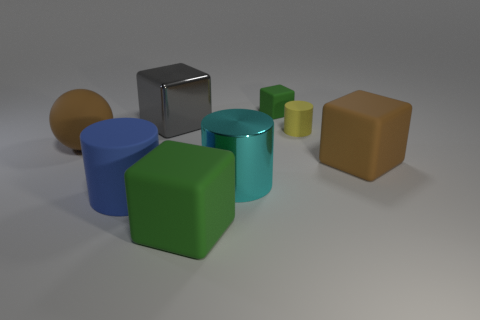There is a tiny object that is the same shape as the large cyan object; what color is it?
Keep it short and to the point. Yellow. There is a big matte ball that is to the left of the tiny yellow rubber thing; does it have the same color as the large metal block?
Offer a terse response. No. There is a rubber object that is the same color as the tiny matte cube; what shape is it?
Your answer should be compact. Cube. What number of large things have the same material as the large green cube?
Keep it short and to the point. 3. How many large shiny objects are behind the brown sphere?
Provide a succinct answer. 1. How big is the shiny cube?
Your answer should be compact. Large. What is the color of the block that is the same size as the yellow matte cylinder?
Give a very brief answer. Green. Is there a large rubber object that has the same color as the small matte block?
Make the answer very short. Yes. What is the gray cube made of?
Make the answer very short. Metal. What number of green things are there?
Your response must be concise. 2. 